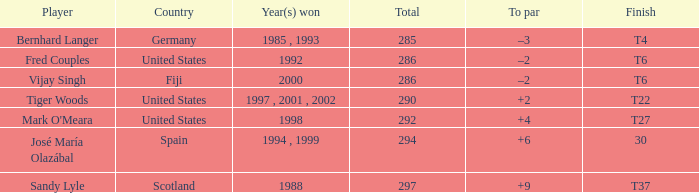What is the total for Bernhard Langer? 1.0. Would you mind parsing the complete table? {'header': ['Player', 'Country', 'Year(s) won', 'Total', 'To par', 'Finish'], 'rows': [['Bernhard Langer', 'Germany', '1985 , 1993', '285', '–3', 'T4'], ['Fred Couples', 'United States', '1992', '286', '–2', 'T6'], ['Vijay Singh', 'Fiji', '2000', '286', '–2', 'T6'], ['Tiger Woods', 'United States', '1997 , 2001 , 2002', '290', '+2', 'T22'], ["Mark O'Meara", 'United States', '1998', '292', '+4', 'T27'], ['José María Olazábal', 'Spain', '1994 , 1999', '294', '+6', '30'], ['Sandy Lyle', 'Scotland', '1988', '297', '+9', 'T37']]} 